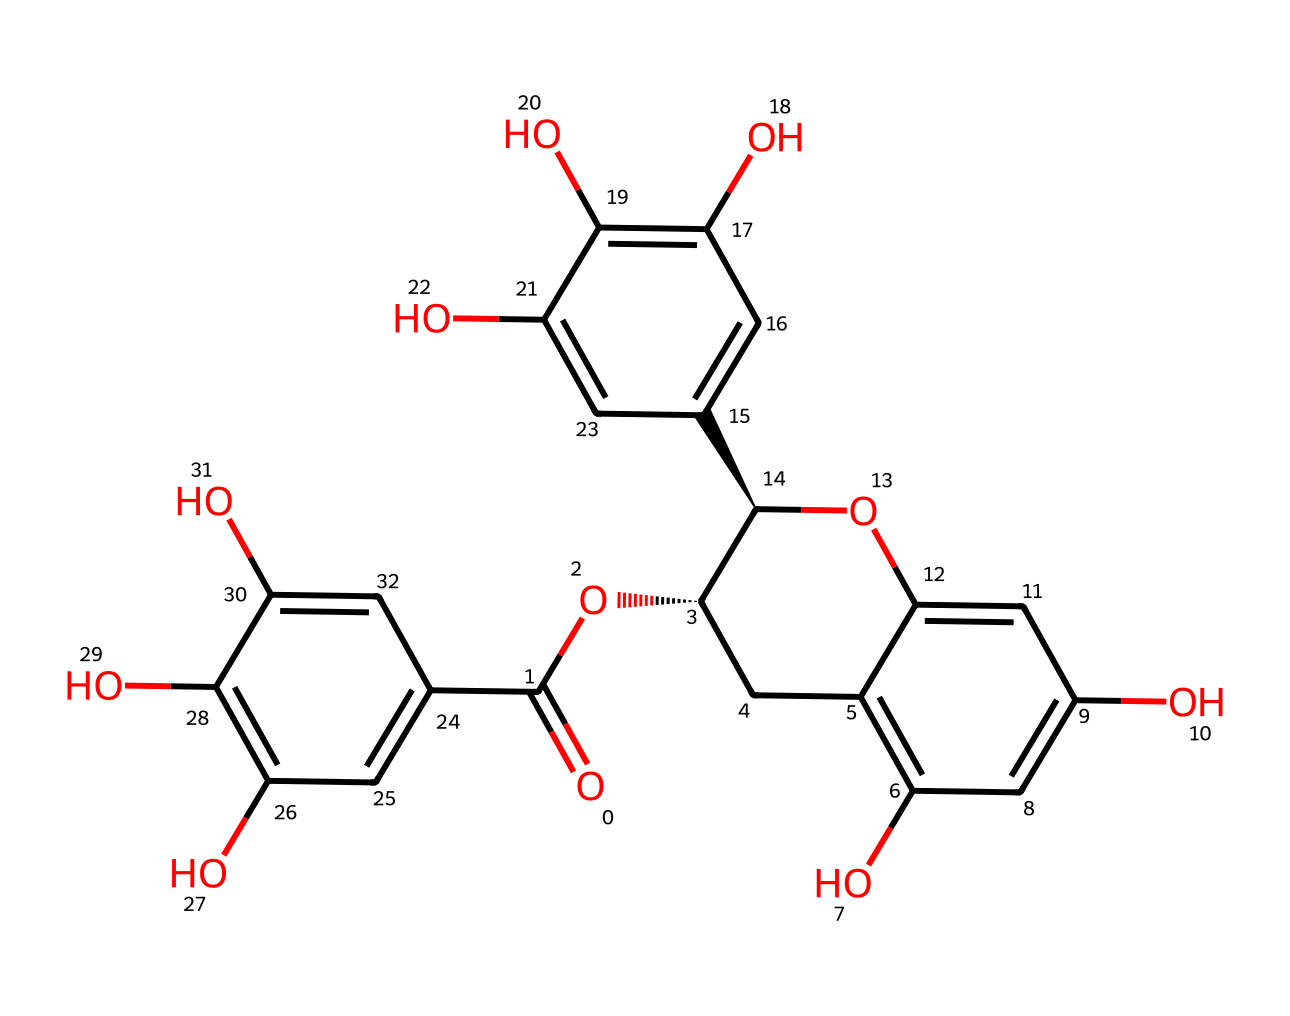How many hydroxyl groups are present in this chemical? In the given chemical structure, each hydroxyl group (-OH) is represented as an oxygen atom bonded to a hydrogen atom. By examining the structure, you can count each position where an -OH group is present. In this case, there are six distinct -OH groups visible.
Answer: six What is the main functional group in this chemical? The primary functional group present in this chemical is the ester group. An ester is characterized by the presence of a carbonyl group (C=O) adjacent to an ether (-O-) link, and this structure shows such an arrangement.
Answer: ester Does this chemical exhibit antioxidant properties? This chemical is identified as a catechin, a type of flavonoid known for its antioxidant properties, which means it can help neutralize free radicals in the body.
Answer: yes What type of bonding is primarily present in this molecule? The primary types of bonding found in this molecule are covalent bonds. These bonds are formed by the sharing of electron pairs between atoms, which is a common characteristic in organic compounds like this catechin structure.
Answer: covalent Is this chemical purely natural, or can it be synthesized? Catechins, including this structure found in Andean green tea, are naturally occurring compounds. However, they can also be synthesized in laboratories for research and pharmaceutical purposes, demonstrating their versatility.
Answer: both How does the number of carbon atoms impact its structure? The number of carbon atoms defines the molecular framework and affects the chemical properties and interactions of the catechin. In this case, the extensive carbon chain contributes to its structural complexity and biological function.
Answer: complexity 